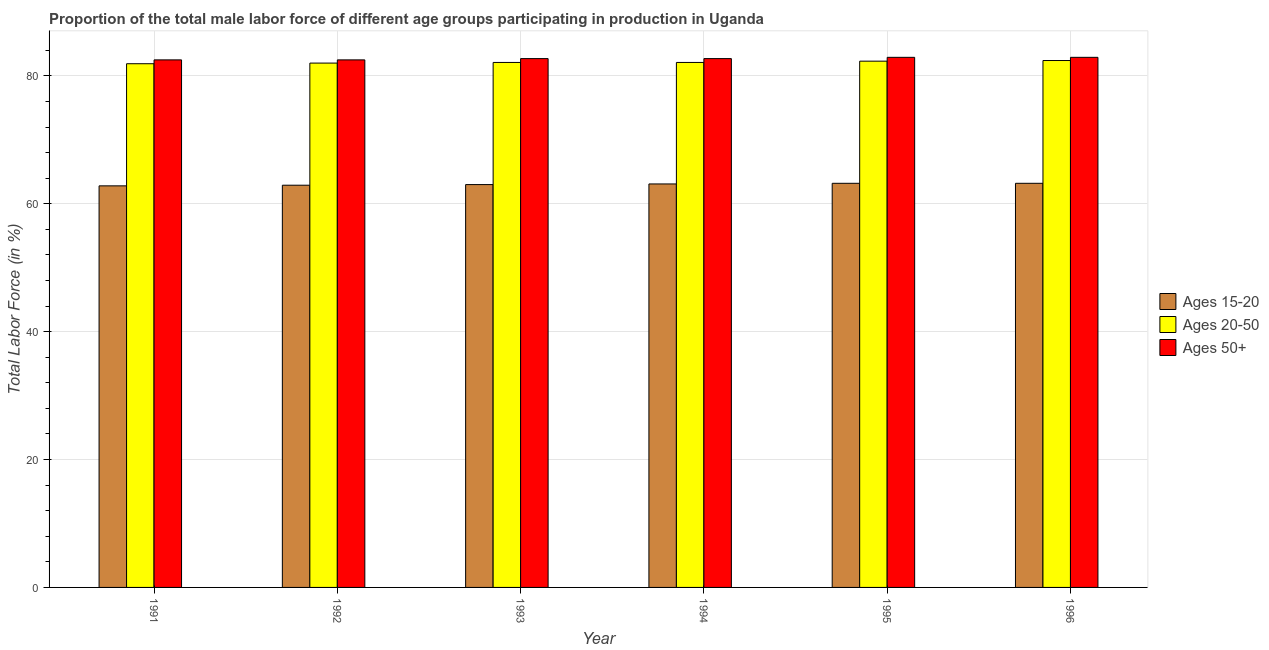How many different coloured bars are there?
Provide a short and direct response. 3. In how many cases, is the number of bars for a given year not equal to the number of legend labels?
Offer a very short reply. 0. What is the percentage of male labor force within the age group 20-50 in 1991?
Provide a short and direct response. 81.9. Across all years, what is the maximum percentage of male labor force within the age group 15-20?
Ensure brevity in your answer.  63.2. Across all years, what is the minimum percentage of male labor force within the age group 20-50?
Provide a succinct answer. 81.9. In which year was the percentage of male labor force within the age group 15-20 minimum?
Keep it short and to the point. 1991. What is the total percentage of male labor force above age 50 in the graph?
Your response must be concise. 496.2. What is the difference between the percentage of male labor force above age 50 in 1991 and that in 1995?
Provide a short and direct response. -0.4. What is the difference between the percentage of male labor force above age 50 in 1996 and the percentage of male labor force within the age group 20-50 in 1992?
Offer a very short reply. 0.4. What is the average percentage of male labor force within the age group 15-20 per year?
Your answer should be very brief. 63.03. In how many years, is the percentage of male labor force within the age group 20-50 greater than 64 %?
Give a very brief answer. 6. What is the difference between the highest and the second highest percentage of male labor force within the age group 15-20?
Your answer should be compact. 0. Is the sum of the percentage of male labor force within the age group 15-20 in 1992 and 1994 greater than the maximum percentage of male labor force above age 50 across all years?
Keep it short and to the point. Yes. What does the 2nd bar from the left in 1991 represents?
Give a very brief answer. Ages 20-50. What does the 1st bar from the right in 1995 represents?
Ensure brevity in your answer.  Ages 50+. How many bars are there?
Keep it short and to the point. 18. Are all the bars in the graph horizontal?
Ensure brevity in your answer.  No. How many years are there in the graph?
Your answer should be compact. 6. What is the difference between two consecutive major ticks on the Y-axis?
Your answer should be very brief. 20. Are the values on the major ticks of Y-axis written in scientific E-notation?
Give a very brief answer. No. Where does the legend appear in the graph?
Provide a short and direct response. Center right. How many legend labels are there?
Make the answer very short. 3. How are the legend labels stacked?
Offer a very short reply. Vertical. What is the title of the graph?
Your answer should be compact. Proportion of the total male labor force of different age groups participating in production in Uganda. What is the label or title of the X-axis?
Make the answer very short. Year. What is the Total Labor Force (in %) of Ages 15-20 in 1991?
Your answer should be very brief. 62.8. What is the Total Labor Force (in %) in Ages 20-50 in 1991?
Your answer should be compact. 81.9. What is the Total Labor Force (in %) of Ages 50+ in 1991?
Provide a succinct answer. 82.5. What is the Total Labor Force (in %) of Ages 15-20 in 1992?
Ensure brevity in your answer.  62.9. What is the Total Labor Force (in %) in Ages 20-50 in 1992?
Give a very brief answer. 82. What is the Total Labor Force (in %) of Ages 50+ in 1992?
Your answer should be very brief. 82.5. What is the Total Labor Force (in %) of Ages 20-50 in 1993?
Your answer should be compact. 82.1. What is the Total Labor Force (in %) in Ages 50+ in 1993?
Ensure brevity in your answer.  82.7. What is the Total Labor Force (in %) in Ages 15-20 in 1994?
Offer a terse response. 63.1. What is the Total Labor Force (in %) in Ages 20-50 in 1994?
Ensure brevity in your answer.  82.1. What is the Total Labor Force (in %) in Ages 50+ in 1994?
Provide a short and direct response. 82.7. What is the Total Labor Force (in %) in Ages 15-20 in 1995?
Offer a very short reply. 63.2. What is the Total Labor Force (in %) of Ages 20-50 in 1995?
Your answer should be compact. 82.3. What is the Total Labor Force (in %) of Ages 50+ in 1995?
Your response must be concise. 82.9. What is the Total Labor Force (in %) in Ages 15-20 in 1996?
Your answer should be compact. 63.2. What is the Total Labor Force (in %) of Ages 20-50 in 1996?
Provide a short and direct response. 82.4. What is the Total Labor Force (in %) in Ages 50+ in 1996?
Make the answer very short. 82.9. Across all years, what is the maximum Total Labor Force (in %) in Ages 15-20?
Your answer should be very brief. 63.2. Across all years, what is the maximum Total Labor Force (in %) in Ages 20-50?
Offer a terse response. 82.4. Across all years, what is the maximum Total Labor Force (in %) in Ages 50+?
Your answer should be very brief. 82.9. Across all years, what is the minimum Total Labor Force (in %) in Ages 15-20?
Your response must be concise. 62.8. Across all years, what is the minimum Total Labor Force (in %) in Ages 20-50?
Give a very brief answer. 81.9. Across all years, what is the minimum Total Labor Force (in %) in Ages 50+?
Provide a succinct answer. 82.5. What is the total Total Labor Force (in %) of Ages 15-20 in the graph?
Offer a terse response. 378.2. What is the total Total Labor Force (in %) in Ages 20-50 in the graph?
Your answer should be compact. 492.8. What is the total Total Labor Force (in %) in Ages 50+ in the graph?
Your response must be concise. 496.2. What is the difference between the Total Labor Force (in %) of Ages 20-50 in 1991 and that in 1992?
Give a very brief answer. -0.1. What is the difference between the Total Labor Force (in %) of Ages 50+ in 1991 and that in 1992?
Your response must be concise. 0. What is the difference between the Total Labor Force (in %) of Ages 15-20 in 1991 and that in 1993?
Provide a succinct answer. -0.2. What is the difference between the Total Labor Force (in %) of Ages 50+ in 1991 and that in 1993?
Your answer should be compact. -0.2. What is the difference between the Total Labor Force (in %) in Ages 15-20 in 1991 and that in 1994?
Make the answer very short. -0.3. What is the difference between the Total Labor Force (in %) in Ages 20-50 in 1991 and that in 1994?
Your answer should be very brief. -0.2. What is the difference between the Total Labor Force (in %) of Ages 15-20 in 1991 and that in 1995?
Give a very brief answer. -0.4. What is the difference between the Total Labor Force (in %) of Ages 50+ in 1991 and that in 1995?
Make the answer very short. -0.4. What is the difference between the Total Labor Force (in %) in Ages 15-20 in 1991 and that in 1996?
Provide a succinct answer. -0.4. What is the difference between the Total Labor Force (in %) of Ages 50+ in 1991 and that in 1996?
Give a very brief answer. -0.4. What is the difference between the Total Labor Force (in %) in Ages 15-20 in 1992 and that in 1993?
Ensure brevity in your answer.  -0.1. What is the difference between the Total Labor Force (in %) of Ages 50+ in 1992 and that in 1993?
Your answer should be very brief. -0.2. What is the difference between the Total Labor Force (in %) of Ages 20-50 in 1992 and that in 1994?
Keep it short and to the point. -0.1. What is the difference between the Total Labor Force (in %) of Ages 15-20 in 1992 and that in 1995?
Make the answer very short. -0.3. What is the difference between the Total Labor Force (in %) of Ages 20-50 in 1992 and that in 1995?
Make the answer very short. -0.3. What is the difference between the Total Labor Force (in %) of Ages 50+ in 1992 and that in 1996?
Your answer should be compact. -0.4. What is the difference between the Total Labor Force (in %) in Ages 50+ in 1993 and that in 1994?
Make the answer very short. 0. What is the difference between the Total Labor Force (in %) of Ages 50+ in 1993 and that in 1995?
Provide a short and direct response. -0.2. What is the difference between the Total Labor Force (in %) in Ages 20-50 in 1994 and that in 1995?
Keep it short and to the point. -0.2. What is the difference between the Total Labor Force (in %) of Ages 15-20 in 1995 and that in 1996?
Keep it short and to the point. 0. What is the difference between the Total Labor Force (in %) of Ages 15-20 in 1991 and the Total Labor Force (in %) of Ages 20-50 in 1992?
Provide a succinct answer. -19.2. What is the difference between the Total Labor Force (in %) in Ages 15-20 in 1991 and the Total Labor Force (in %) in Ages 50+ in 1992?
Provide a short and direct response. -19.7. What is the difference between the Total Labor Force (in %) of Ages 15-20 in 1991 and the Total Labor Force (in %) of Ages 20-50 in 1993?
Make the answer very short. -19.3. What is the difference between the Total Labor Force (in %) of Ages 15-20 in 1991 and the Total Labor Force (in %) of Ages 50+ in 1993?
Provide a succinct answer. -19.9. What is the difference between the Total Labor Force (in %) in Ages 20-50 in 1991 and the Total Labor Force (in %) in Ages 50+ in 1993?
Your response must be concise. -0.8. What is the difference between the Total Labor Force (in %) of Ages 15-20 in 1991 and the Total Labor Force (in %) of Ages 20-50 in 1994?
Give a very brief answer. -19.3. What is the difference between the Total Labor Force (in %) in Ages 15-20 in 1991 and the Total Labor Force (in %) in Ages 50+ in 1994?
Make the answer very short. -19.9. What is the difference between the Total Labor Force (in %) in Ages 20-50 in 1991 and the Total Labor Force (in %) in Ages 50+ in 1994?
Offer a very short reply. -0.8. What is the difference between the Total Labor Force (in %) of Ages 15-20 in 1991 and the Total Labor Force (in %) of Ages 20-50 in 1995?
Provide a short and direct response. -19.5. What is the difference between the Total Labor Force (in %) of Ages 15-20 in 1991 and the Total Labor Force (in %) of Ages 50+ in 1995?
Make the answer very short. -20.1. What is the difference between the Total Labor Force (in %) in Ages 15-20 in 1991 and the Total Labor Force (in %) in Ages 20-50 in 1996?
Provide a succinct answer. -19.6. What is the difference between the Total Labor Force (in %) of Ages 15-20 in 1991 and the Total Labor Force (in %) of Ages 50+ in 1996?
Your answer should be very brief. -20.1. What is the difference between the Total Labor Force (in %) in Ages 15-20 in 1992 and the Total Labor Force (in %) in Ages 20-50 in 1993?
Your answer should be compact. -19.2. What is the difference between the Total Labor Force (in %) in Ages 15-20 in 1992 and the Total Labor Force (in %) in Ages 50+ in 1993?
Your response must be concise. -19.8. What is the difference between the Total Labor Force (in %) of Ages 15-20 in 1992 and the Total Labor Force (in %) of Ages 20-50 in 1994?
Offer a very short reply. -19.2. What is the difference between the Total Labor Force (in %) in Ages 15-20 in 1992 and the Total Labor Force (in %) in Ages 50+ in 1994?
Your answer should be compact. -19.8. What is the difference between the Total Labor Force (in %) in Ages 15-20 in 1992 and the Total Labor Force (in %) in Ages 20-50 in 1995?
Offer a terse response. -19.4. What is the difference between the Total Labor Force (in %) of Ages 15-20 in 1992 and the Total Labor Force (in %) of Ages 20-50 in 1996?
Your answer should be compact. -19.5. What is the difference between the Total Labor Force (in %) in Ages 20-50 in 1992 and the Total Labor Force (in %) in Ages 50+ in 1996?
Your answer should be compact. -0.9. What is the difference between the Total Labor Force (in %) of Ages 15-20 in 1993 and the Total Labor Force (in %) of Ages 20-50 in 1994?
Your answer should be very brief. -19.1. What is the difference between the Total Labor Force (in %) in Ages 15-20 in 1993 and the Total Labor Force (in %) in Ages 50+ in 1994?
Give a very brief answer. -19.7. What is the difference between the Total Labor Force (in %) of Ages 15-20 in 1993 and the Total Labor Force (in %) of Ages 20-50 in 1995?
Your response must be concise. -19.3. What is the difference between the Total Labor Force (in %) in Ages 15-20 in 1993 and the Total Labor Force (in %) in Ages 50+ in 1995?
Give a very brief answer. -19.9. What is the difference between the Total Labor Force (in %) of Ages 15-20 in 1993 and the Total Labor Force (in %) of Ages 20-50 in 1996?
Offer a very short reply. -19.4. What is the difference between the Total Labor Force (in %) in Ages 15-20 in 1993 and the Total Labor Force (in %) in Ages 50+ in 1996?
Your answer should be compact. -19.9. What is the difference between the Total Labor Force (in %) in Ages 20-50 in 1993 and the Total Labor Force (in %) in Ages 50+ in 1996?
Provide a short and direct response. -0.8. What is the difference between the Total Labor Force (in %) of Ages 15-20 in 1994 and the Total Labor Force (in %) of Ages 20-50 in 1995?
Keep it short and to the point. -19.2. What is the difference between the Total Labor Force (in %) in Ages 15-20 in 1994 and the Total Labor Force (in %) in Ages 50+ in 1995?
Offer a terse response. -19.8. What is the difference between the Total Labor Force (in %) of Ages 15-20 in 1994 and the Total Labor Force (in %) of Ages 20-50 in 1996?
Your answer should be very brief. -19.3. What is the difference between the Total Labor Force (in %) of Ages 15-20 in 1994 and the Total Labor Force (in %) of Ages 50+ in 1996?
Keep it short and to the point. -19.8. What is the difference between the Total Labor Force (in %) in Ages 15-20 in 1995 and the Total Labor Force (in %) in Ages 20-50 in 1996?
Your response must be concise. -19.2. What is the difference between the Total Labor Force (in %) of Ages 15-20 in 1995 and the Total Labor Force (in %) of Ages 50+ in 1996?
Provide a succinct answer. -19.7. What is the average Total Labor Force (in %) in Ages 15-20 per year?
Keep it short and to the point. 63.03. What is the average Total Labor Force (in %) of Ages 20-50 per year?
Give a very brief answer. 82.13. What is the average Total Labor Force (in %) of Ages 50+ per year?
Offer a very short reply. 82.7. In the year 1991, what is the difference between the Total Labor Force (in %) in Ages 15-20 and Total Labor Force (in %) in Ages 20-50?
Your answer should be compact. -19.1. In the year 1991, what is the difference between the Total Labor Force (in %) of Ages 15-20 and Total Labor Force (in %) of Ages 50+?
Offer a terse response. -19.7. In the year 1991, what is the difference between the Total Labor Force (in %) in Ages 20-50 and Total Labor Force (in %) in Ages 50+?
Give a very brief answer. -0.6. In the year 1992, what is the difference between the Total Labor Force (in %) of Ages 15-20 and Total Labor Force (in %) of Ages 20-50?
Provide a succinct answer. -19.1. In the year 1992, what is the difference between the Total Labor Force (in %) of Ages 15-20 and Total Labor Force (in %) of Ages 50+?
Offer a very short reply. -19.6. In the year 1993, what is the difference between the Total Labor Force (in %) of Ages 15-20 and Total Labor Force (in %) of Ages 20-50?
Provide a short and direct response. -19.1. In the year 1993, what is the difference between the Total Labor Force (in %) of Ages 15-20 and Total Labor Force (in %) of Ages 50+?
Give a very brief answer. -19.7. In the year 1994, what is the difference between the Total Labor Force (in %) in Ages 15-20 and Total Labor Force (in %) in Ages 20-50?
Provide a succinct answer. -19. In the year 1994, what is the difference between the Total Labor Force (in %) in Ages 15-20 and Total Labor Force (in %) in Ages 50+?
Ensure brevity in your answer.  -19.6. In the year 1994, what is the difference between the Total Labor Force (in %) in Ages 20-50 and Total Labor Force (in %) in Ages 50+?
Keep it short and to the point. -0.6. In the year 1995, what is the difference between the Total Labor Force (in %) in Ages 15-20 and Total Labor Force (in %) in Ages 20-50?
Ensure brevity in your answer.  -19.1. In the year 1995, what is the difference between the Total Labor Force (in %) of Ages 15-20 and Total Labor Force (in %) of Ages 50+?
Give a very brief answer. -19.7. In the year 1996, what is the difference between the Total Labor Force (in %) in Ages 15-20 and Total Labor Force (in %) in Ages 20-50?
Provide a short and direct response. -19.2. In the year 1996, what is the difference between the Total Labor Force (in %) in Ages 15-20 and Total Labor Force (in %) in Ages 50+?
Provide a succinct answer. -19.7. In the year 1996, what is the difference between the Total Labor Force (in %) in Ages 20-50 and Total Labor Force (in %) in Ages 50+?
Your answer should be compact. -0.5. What is the ratio of the Total Labor Force (in %) of Ages 15-20 in 1991 to that in 1992?
Keep it short and to the point. 1. What is the ratio of the Total Labor Force (in %) of Ages 20-50 in 1991 to that in 1992?
Keep it short and to the point. 1. What is the ratio of the Total Labor Force (in %) in Ages 50+ in 1991 to that in 1992?
Your response must be concise. 1. What is the ratio of the Total Labor Force (in %) in Ages 15-20 in 1991 to that in 1993?
Provide a short and direct response. 1. What is the ratio of the Total Labor Force (in %) of Ages 50+ in 1991 to that in 1993?
Keep it short and to the point. 1. What is the ratio of the Total Labor Force (in %) in Ages 50+ in 1991 to that in 1995?
Your answer should be compact. 1. What is the ratio of the Total Labor Force (in %) of Ages 50+ in 1991 to that in 1996?
Make the answer very short. 1. What is the ratio of the Total Labor Force (in %) in Ages 15-20 in 1992 to that in 1993?
Offer a very short reply. 1. What is the ratio of the Total Labor Force (in %) of Ages 20-50 in 1992 to that in 1993?
Keep it short and to the point. 1. What is the ratio of the Total Labor Force (in %) of Ages 50+ in 1992 to that in 1993?
Your answer should be very brief. 1. What is the ratio of the Total Labor Force (in %) in Ages 50+ in 1992 to that in 1994?
Provide a short and direct response. 1. What is the ratio of the Total Labor Force (in %) in Ages 15-20 in 1992 to that in 1995?
Ensure brevity in your answer.  1. What is the ratio of the Total Labor Force (in %) of Ages 50+ in 1992 to that in 1995?
Make the answer very short. 1. What is the ratio of the Total Labor Force (in %) in Ages 15-20 in 1992 to that in 1996?
Provide a succinct answer. 1. What is the ratio of the Total Labor Force (in %) of Ages 15-20 in 1993 to that in 1994?
Give a very brief answer. 1. What is the ratio of the Total Labor Force (in %) of Ages 50+ in 1994 to that in 1995?
Provide a short and direct response. 1. What is the ratio of the Total Labor Force (in %) of Ages 20-50 in 1994 to that in 1996?
Keep it short and to the point. 1. What is the ratio of the Total Labor Force (in %) of Ages 20-50 in 1995 to that in 1996?
Your response must be concise. 1. What is the difference between the highest and the second highest Total Labor Force (in %) of Ages 15-20?
Give a very brief answer. 0. What is the difference between the highest and the second highest Total Labor Force (in %) in Ages 20-50?
Offer a terse response. 0.1. What is the difference between the highest and the second highest Total Labor Force (in %) in Ages 50+?
Offer a terse response. 0. What is the difference between the highest and the lowest Total Labor Force (in %) of Ages 50+?
Provide a succinct answer. 0.4. 